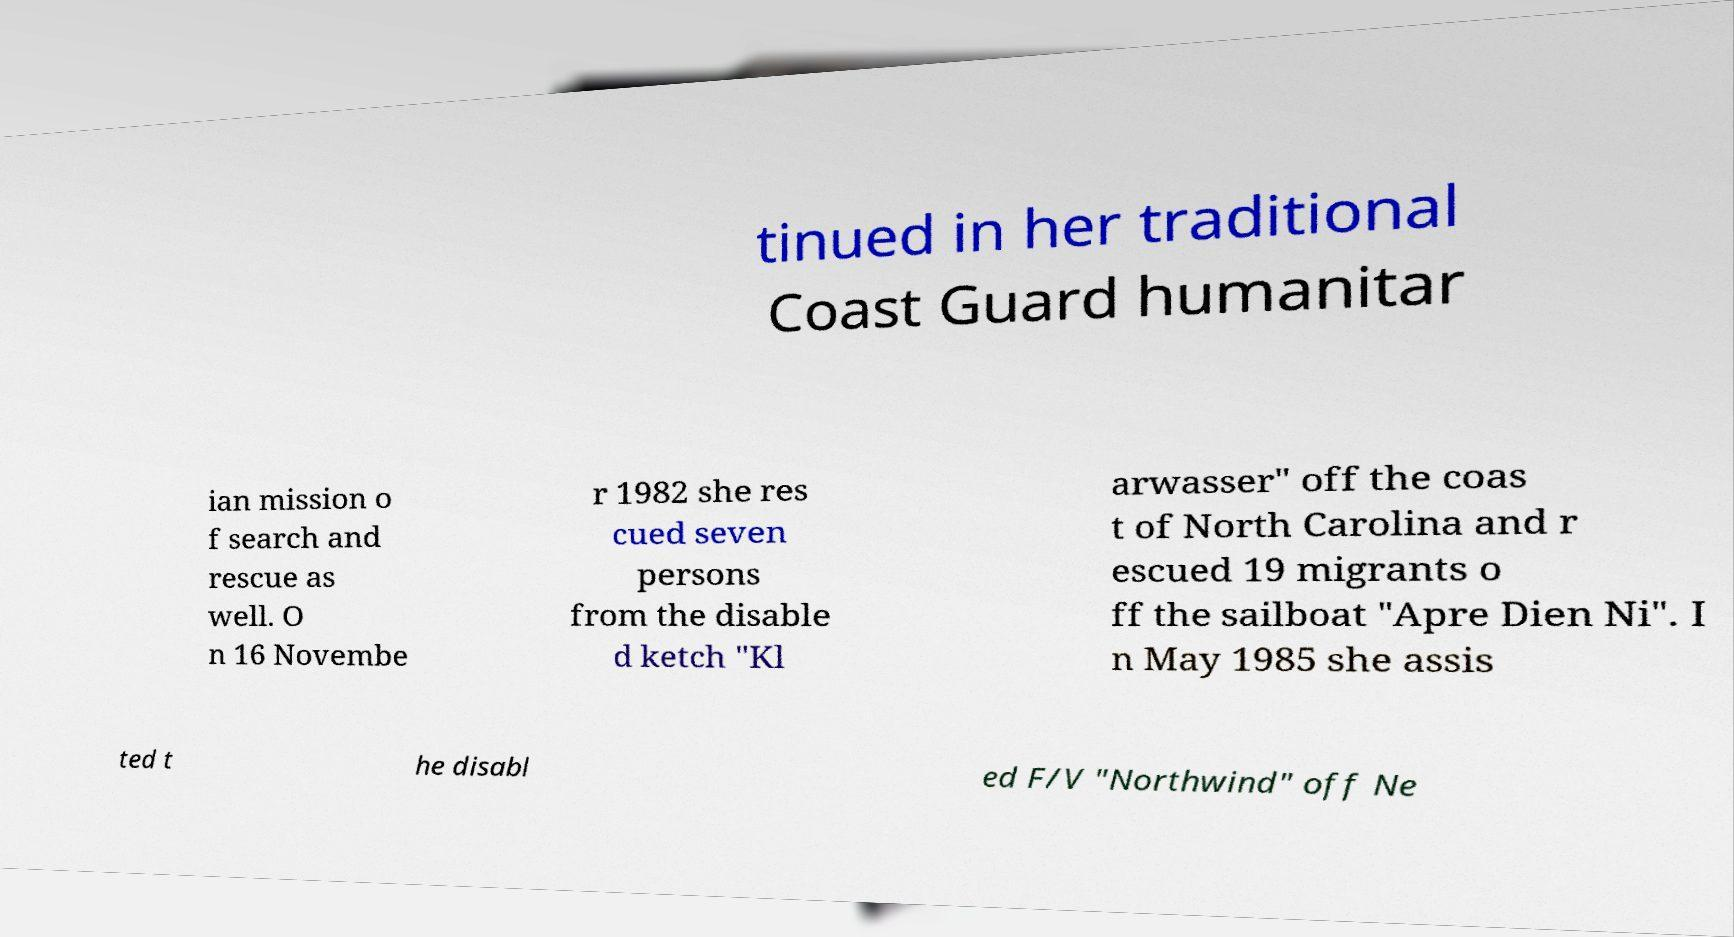Can you read and provide the text displayed in the image?This photo seems to have some interesting text. Can you extract and type it out for me? tinued in her traditional Coast Guard humanitar ian mission o f search and rescue as well. O n 16 Novembe r 1982 she res cued seven persons from the disable d ketch "Kl arwasser" off the coas t of North Carolina and r escued 19 migrants o ff the sailboat "Apre Dien Ni". I n May 1985 she assis ted t he disabl ed F/V "Northwind" off Ne 